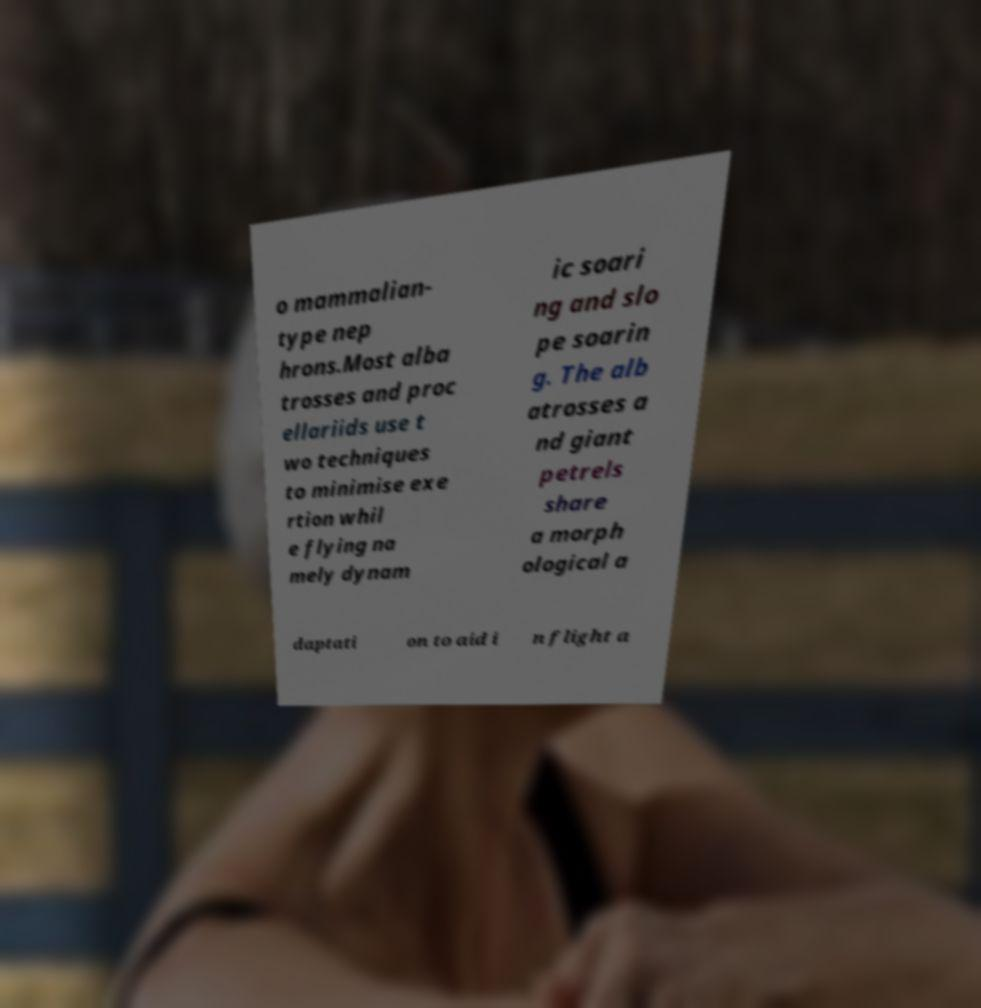There's text embedded in this image that I need extracted. Can you transcribe it verbatim? o mammalian- type nep hrons.Most alba trosses and proc ellariids use t wo techniques to minimise exe rtion whil e flying na mely dynam ic soari ng and slo pe soarin g. The alb atrosses a nd giant petrels share a morph ological a daptati on to aid i n flight a 